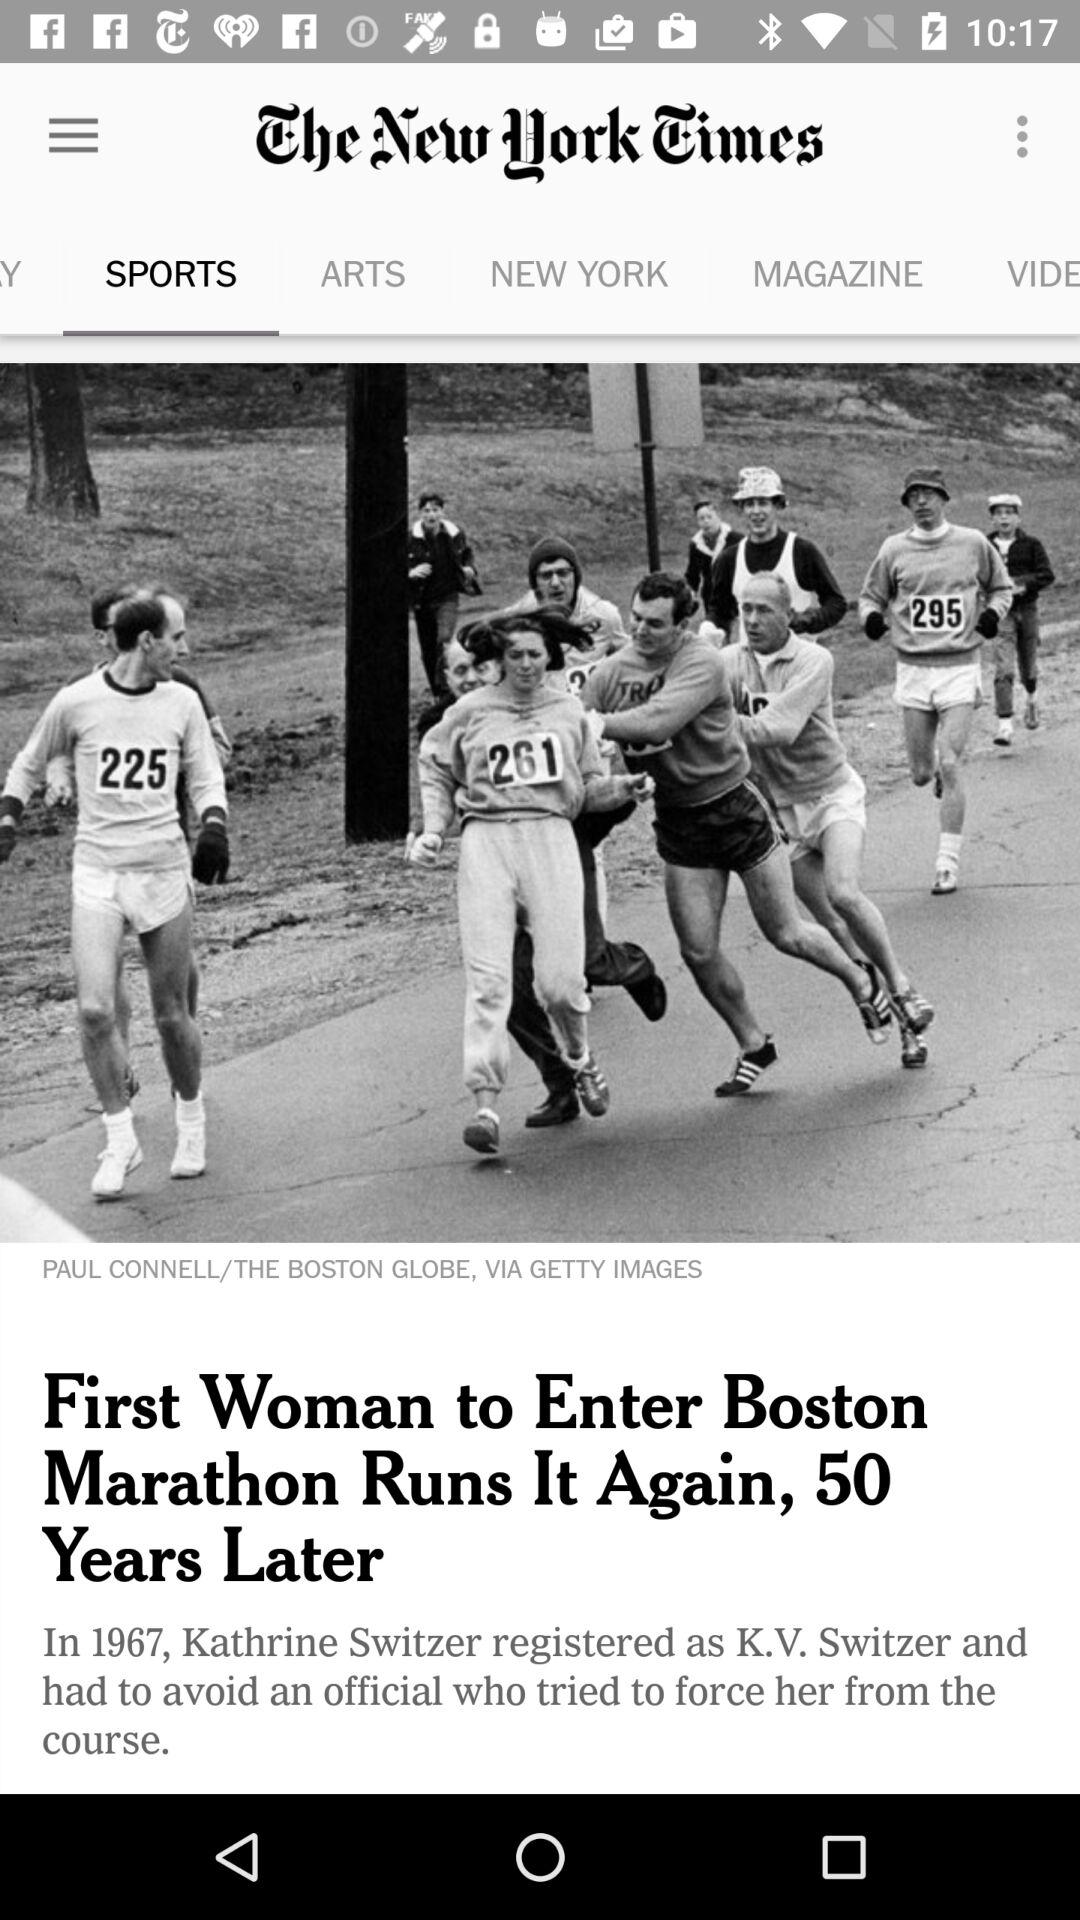How many years after Kathrine Switzer registered as K.V. Switzer did she run the Boston Marathon again?
Answer the question using a single word or phrase. 50 